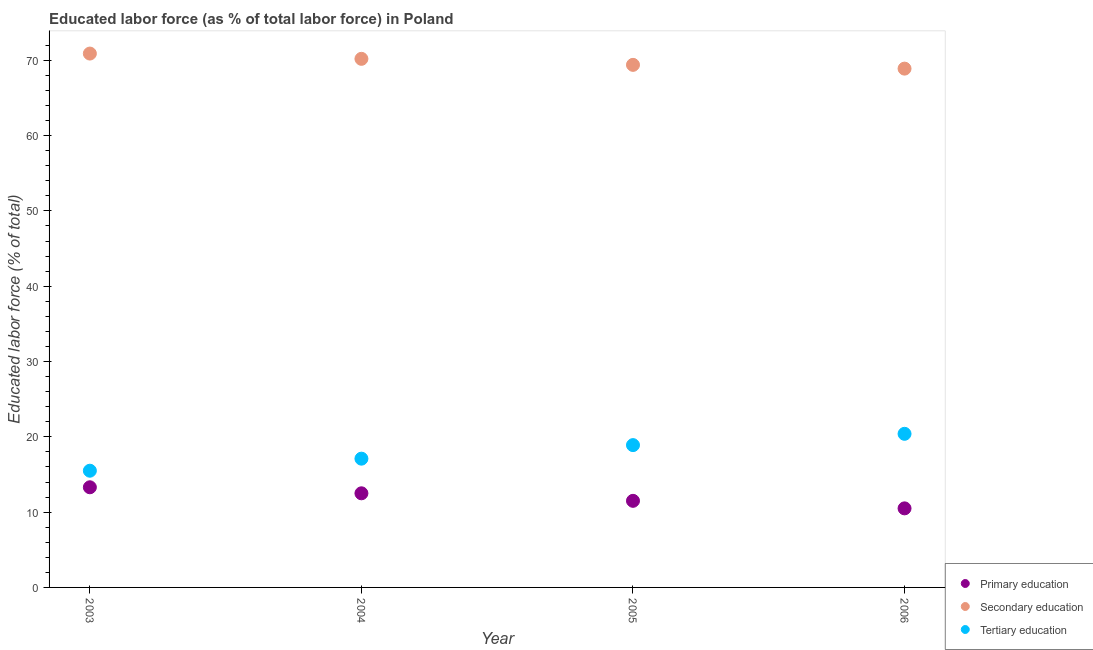How many different coloured dotlines are there?
Ensure brevity in your answer.  3. Is the number of dotlines equal to the number of legend labels?
Keep it short and to the point. Yes. What is the percentage of labor force who received primary education in 2003?
Provide a short and direct response. 13.3. Across all years, what is the maximum percentage of labor force who received primary education?
Your response must be concise. 13.3. In which year was the percentage of labor force who received secondary education minimum?
Ensure brevity in your answer.  2006. What is the total percentage of labor force who received primary education in the graph?
Offer a terse response. 47.8. What is the difference between the percentage of labor force who received tertiary education in 2003 and that in 2004?
Offer a terse response. -1.6. What is the difference between the percentage of labor force who received tertiary education in 2003 and the percentage of labor force who received secondary education in 2004?
Ensure brevity in your answer.  -54.7. What is the average percentage of labor force who received primary education per year?
Ensure brevity in your answer.  11.95. In the year 2005, what is the difference between the percentage of labor force who received primary education and percentage of labor force who received secondary education?
Offer a very short reply. -57.9. In how many years, is the percentage of labor force who received tertiary education greater than 4 %?
Keep it short and to the point. 4. What is the ratio of the percentage of labor force who received tertiary education in 2003 to that in 2004?
Provide a succinct answer. 0.91. Is the difference between the percentage of labor force who received secondary education in 2003 and 2004 greater than the difference between the percentage of labor force who received tertiary education in 2003 and 2004?
Provide a short and direct response. Yes. What is the difference between the highest and the second highest percentage of labor force who received tertiary education?
Make the answer very short. 1.5. What is the difference between the highest and the lowest percentage of labor force who received primary education?
Your response must be concise. 2.8. Is the sum of the percentage of labor force who received secondary education in 2003 and 2005 greater than the maximum percentage of labor force who received primary education across all years?
Your answer should be compact. Yes. Is it the case that in every year, the sum of the percentage of labor force who received primary education and percentage of labor force who received secondary education is greater than the percentage of labor force who received tertiary education?
Your response must be concise. Yes. Does the percentage of labor force who received tertiary education monotonically increase over the years?
Make the answer very short. Yes. Is the percentage of labor force who received primary education strictly less than the percentage of labor force who received secondary education over the years?
Your answer should be compact. Yes. What is the difference between two consecutive major ticks on the Y-axis?
Your response must be concise. 10. Does the graph contain any zero values?
Offer a terse response. No. Does the graph contain grids?
Give a very brief answer. No. Where does the legend appear in the graph?
Offer a very short reply. Bottom right. What is the title of the graph?
Provide a succinct answer. Educated labor force (as % of total labor force) in Poland. What is the label or title of the X-axis?
Your response must be concise. Year. What is the label or title of the Y-axis?
Ensure brevity in your answer.  Educated labor force (% of total). What is the Educated labor force (% of total) of Primary education in 2003?
Offer a terse response. 13.3. What is the Educated labor force (% of total) in Secondary education in 2003?
Your answer should be compact. 70.9. What is the Educated labor force (% of total) in Tertiary education in 2003?
Offer a terse response. 15.5. What is the Educated labor force (% of total) of Primary education in 2004?
Ensure brevity in your answer.  12.5. What is the Educated labor force (% of total) of Secondary education in 2004?
Ensure brevity in your answer.  70.2. What is the Educated labor force (% of total) in Tertiary education in 2004?
Provide a succinct answer. 17.1. What is the Educated labor force (% of total) in Secondary education in 2005?
Your answer should be very brief. 69.4. What is the Educated labor force (% of total) in Tertiary education in 2005?
Your answer should be very brief. 18.9. What is the Educated labor force (% of total) of Primary education in 2006?
Your answer should be very brief. 10.5. What is the Educated labor force (% of total) in Secondary education in 2006?
Ensure brevity in your answer.  68.9. What is the Educated labor force (% of total) in Tertiary education in 2006?
Ensure brevity in your answer.  20.4. Across all years, what is the maximum Educated labor force (% of total) of Primary education?
Your answer should be very brief. 13.3. Across all years, what is the maximum Educated labor force (% of total) of Secondary education?
Offer a very short reply. 70.9. Across all years, what is the maximum Educated labor force (% of total) of Tertiary education?
Make the answer very short. 20.4. Across all years, what is the minimum Educated labor force (% of total) of Secondary education?
Provide a short and direct response. 68.9. Across all years, what is the minimum Educated labor force (% of total) in Tertiary education?
Your response must be concise. 15.5. What is the total Educated labor force (% of total) in Primary education in the graph?
Make the answer very short. 47.8. What is the total Educated labor force (% of total) of Secondary education in the graph?
Ensure brevity in your answer.  279.4. What is the total Educated labor force (% of total) of Tertiary education in the graph?
Your answer should be very brief. 71.9. What is the difference between the Educated labor force (% of total) in Tertiary education in 2003 and that in 2004?
Your answer should be very brief. -1.6. What is the difference between the Educated labor force (% of total) in Tertiary education in 2003 and that in 2005?
Offer a terse response. -3.4. What is the difference between the Educated labor force (% of total) in Primary education in 2003 and that in 2006?
Your response must be concise. 2.8. What is the difference between the Educated labor force (% of total) of Secondary education in 2003 and that in 2006?
Your answer should be very brief. 2. What is the difference between the Educated labor force (% of total) in Tertiary education in 2003 and that in 2006?
Offer a very short reply. -4.9. What is the difference between the Educated labor force (% of total) in Secondary education in 2004 and that in 2005?
Provide a short and direct response. 0.8. What is the difference between the Educated labor force (% of total) in Tertiary education in 2004 and that in 2005?
Your answer should be very brief. -1.8. What is the difference between the Educated labor force (% of total) in Secondary education in 2004 and that in 2006?
Your answer should be compact. 1.3. What is the difference between the Educated labor force (% of total) in Primary education in 2005 and that in 2006?
Your answer should be very brief. 1. What is the difference between the Educated labor force (% of total) in Tertiary education in 2005 and that in 2006?
Your response must be concise. -1.5. What is the difference between the Educated labor force (% of total) of Primary education in 2003 and the Educated labor force (% of total) of Secondary education in 2004?
Ensure brevity in your answer.  -56.9. What is the difference between the Educated labor force (% of total) in Primary education in 2003 and the Educated labor force (% of total) in Tertiary education in 2004?
Give a very brief answer. -3.8. What is the difference between the Educated labor force (% of total) of Secondary education in 2003 and the Educated labor force (% of total) of Tertiary education in 2004?
Give a very brief answer. 53.8. What is the difference between the Educated labor force (% of total) in Primary education in 2003 and the Educated labor force (% of total) in Secondary education in 2005?
Provide a short and direct response. -56.1. What is the difference between the Educated labor force (% of total) in Primary education in 2003 and the Educated labor force (% of total) in Tertiary education in 2005?
Provide a succinct answer. -5.6. What is the difference between the Educated labor force (% of total) in Secondary education in 2003 and the Educated labor force (% of total) in Tertiary education in 2005?
Your answer should be very brief. 52. What is the difference between the Educated labor force (% of total) in Primary education in 2003 and the Educated labor force (% of total) in Secondary education in 2006?
Make the answer very short. -55.6. What is the difference between the Educated labor force (% of total) in Secondary education in 2003 and the Educated labor force (% of total) in Tertiary education in 2006?
Make the answer very short. 50.5. What is the difference between the Educated labor force (% of total) in Primary education in 2004 and the Educated labor force (% of total) in Secondary education in 2005?
Your answer should be compact. -56.9. What is the difference between the Educated labor force (% of total) of Secondary education in 2004 and the Educated labor force (% of total) of Tertiary education in 2005?
Keep it short and to the point. 51.3. What is the difference between the Educated labor force (% of total) of Primary education in 2004 and the Educated labor force (% of total) of Secondary education in 2006?
Give a very brief answer. -56.4. What is the difference between the Educated labor force (% of total) of Secondary education in 2004 and the Educated labor force (% of total) of Tertiary education in 2006?
Your answer should be compact. 49.8. What is the difference between the Educated labor force (% of total) in Primary education in 2005 and the Educated labor force (% of total) in Secondary education in 2006?
Your answer should be compact. -57.4. What is the difference between the Educated labor force (% of total) of Primary education in 2005 and the Educated labor force (% of total) of Tertiary education in 2006?
Provide a short and direct response. -8.9. What is the average Educated labor force (% of total) in Primary education per year?
Give a very brief answer. 11.95. What is the average Educated labor force (% of total) in Secondary education per year?
Ensure brevity in your answer.  69.85. What is the average Educated labor force (% of total) in Tertiary education per year?
Offer a very short reply. 17.98. In the year 2003, what is the difference between the Educated labor force (% of total) of Primary education and Educated labor force (% of total) of Secondary education?
Your answer should be very brief. -57.6. In the year 2003, what is the difference between the Educated labor force (% of total) in Primary education and Educated labor force (% of total) in Tertiary education?
Provide a short and direct response. -2.2. In the year 2003, what is the difference between the Educated labor force (% of total) in Secondary education and Educated labor force (% of total) in Tertiary education?
Make the answer very short. 55.4. In the year 2004, what is the difference between the Educated labor force (% of total) in Primary education and Educated labor force (% of total) in Secondary education?
Your answer should be compact. -57.7. In the year 2004, what is the difference between the Educated labor force (% of total) in Primary education and Educated labor force (% of total) in Tertiary education?
Your answer should be very brief. -4.6. In the year 2004, what is the difference between the Educated labor force (% of total) of Secondary education and Educated labor force (% of total) of Tertiary education?
Provide a succinct answer. 53.1. In the year 2005, what is the difference between the Educated labor force (% of total) in Primary education and Educated labor force (% of total) in Secondary education?
Your answer should be very brief. -57.9. In the year 2005, what is the difference between the Educated labor force (% of total) in Primary education and Educated labor force (% of total) in Tertiary education?
Provide a succinct answer. -7.4. In the year 2005, what is the difference between the Educated labor force (% of total) in Secondary education and Educated labor force (% of total) in Tertiary education?
Your answer should be very brief. 50.5. In the year 2006, what is the difference between the Educated labor force (% of total) of Primary education and Educated labor force (% of total) of Secondary education?
Your answer should be very brief. -58.4. In the year 2006, what is the difference between the Educated labor force (% of total) in Secondary education and Educated labor force (% of total) in Tertiary education?
Offer a very short reply. 48.5. What is the ratio of the Educated labor force (% of total) in Primary education in 2003 to that in 2004?
Provide a succinct answer. 1.06. What is the ratio of the Educated labor force (% of total) in Tertiary education in 2003 to that in 2004?
Your response must be concise. 0.91. What is the ratio of the Educated labor force (% of total) of Primary education in 2003 to that in 2005?
Your answer should be compact. 1.16. What is the ratio of the Educated labor force (% of total) of Secondary education in 2003 to that in 2005?
Give a very brief answer. 1.02. What is the ratio of the Educated labor force (% of total) of Tertiary education in 2003 to that in 2005?
Ensure brevity in your answer.  0.82. What is the ratio of the Educated labor force (% of total) in Primary education in 2003 to that in 2006?
Provide a succinct answer. 1.27. What is the ratio of the Educated labor force (% of total) of Secondary education in 2003 to that in 2006?
Provide a short and direct response. 1.03. What is the ratio of the Educated labor force (% of total) of Tertiary education in 2003 to that in 2006?
Provide a short and direct response. 0.76. What is the ratio of the Educated labor force (% of total) in Primary education in 2004 to that in 2005?
Ensure brevity in your answer.  1.09. What is the ratio of the Educated labor force (% of total) in Secondary education in 2004 to that in 2005?
Keep it short and to the point. 1.01. What is the ratio of the Educated labor force (% of total) of Tertiary education in 2004 to that in 2005?
Give a very brief answer. 0.9. What is the ratio of the Educated labor force (% of total) of Primary education in 2004 to that in 2006?
Provide a short and direct response. 1.19. What is the ratio of the Educated labor force (% of total) of Secondary education in 2004 to that in 2006?
Provide a succinct answer. 1.02. What is the ratio of the Educated labor force (% of total) of Tertiary education in 2004 to that in 2006?
Offer a terse response. 0.84. What is the ratio of the Educated labor force (% of total) in Primary education in 2005 to that in 2006?
Your answer should be very brief. 1.1. What is the ratio of the Educated labor force (% of total) of Secondary education in 2005 to that in 2006?
Ensure brevity in your answer.  1.01. What is the ratio of the Educated labor force (% of total) of Tertiary education in 2005 to that in 2006?
Offer a very short reply. 0.93. What is the difference between the highest and the second highest Educated labor force (% of total) in Secondary education?
Offer a terse response. 0.7. What is the difference between the highest and the second highest Educated labor force (% of total) in Tertiary education?
Your response must be concise. 1.5. What is the difference between the highest and the lowest Educated labor force (% of total) of Primary education?
Ensure brevity in your answer.  2.8. What is the difference between the highest and the lowest Educated labor force (% of total) in Secondary education?
Ensure brevity in your answer.  2. What is the difference between the highest and the lowest Educated labor force (% of total) of Tertiary education?
Provide a short and direct response. 4.9. 